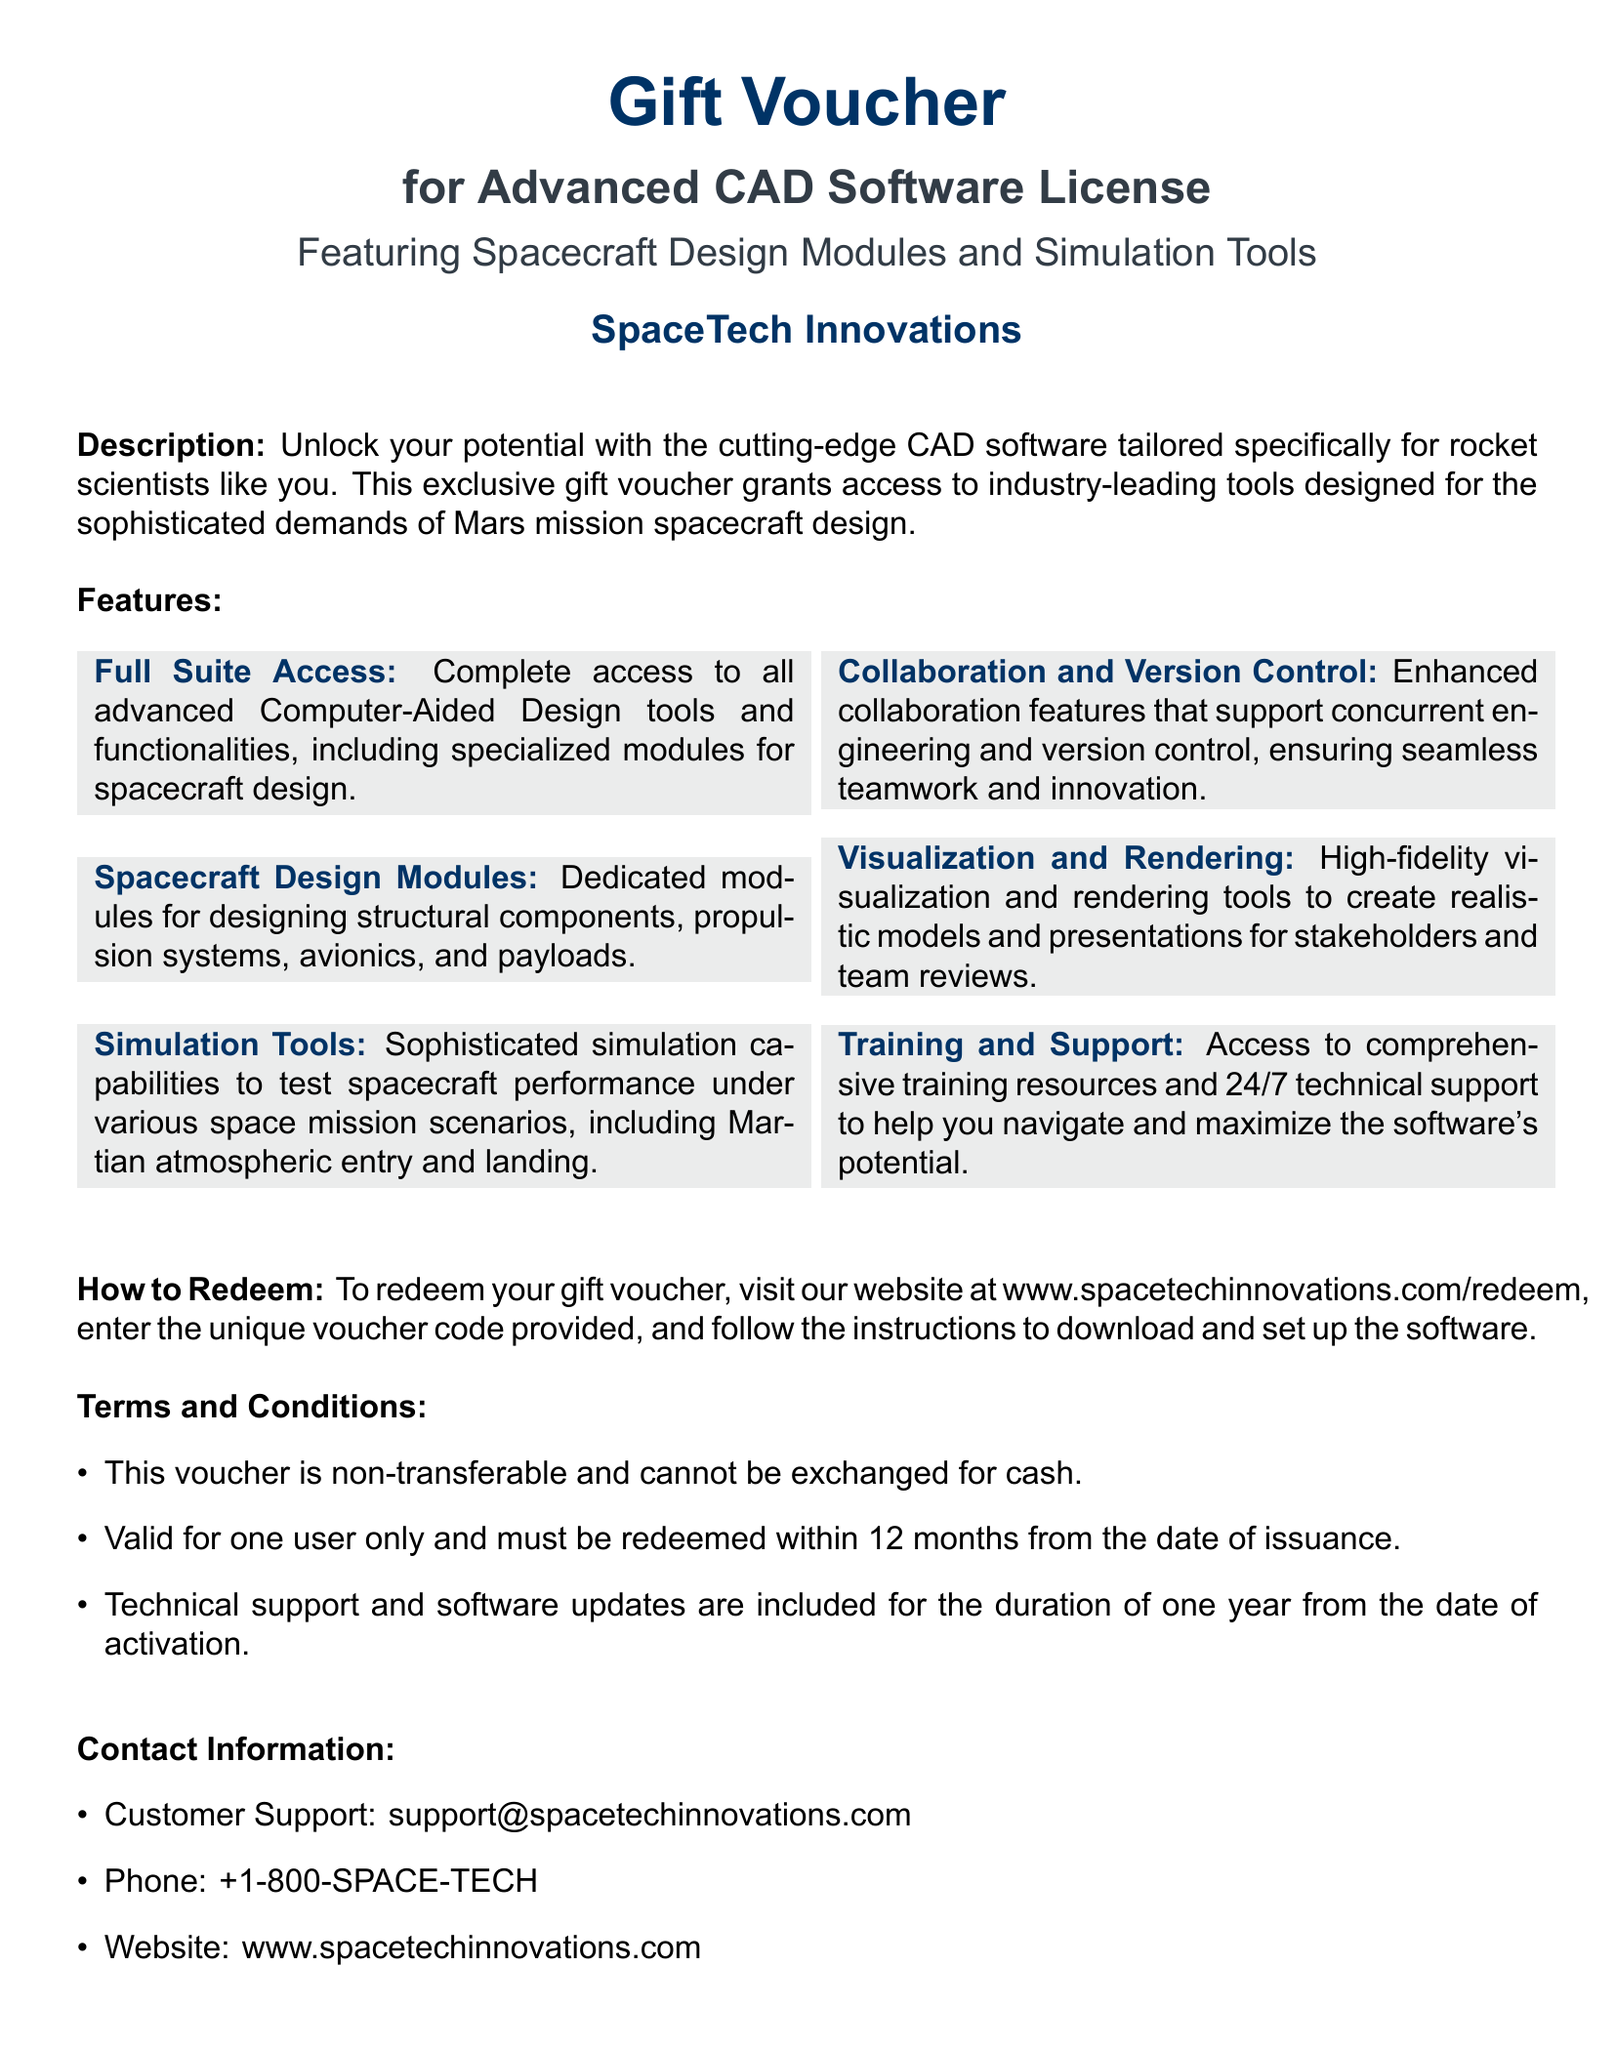What is the title of the gift voucher? The title of the gift voucher is explicitly stated at the top of the document.
Answer: Gift Voucher Who is the issuer of the voucher? The issuer of the voucher is mentioned below the title in the document.
Answer: SpaceTech Innovations What is included in the voucher? The document describes the contents of the voucher in the description section.
Answer: Advanced CAD Software License How many months is the redemption period? The terms section specifies the timeframe within which the voucher must be redeemed.
Answer: 12 months What does "Full Suite Access" provide? The features section details what is included under "Full Suite Access".
Answer: Complete access to all advanced Computer-Aided Design tools What type of support is offered? The features section mentions the support that comes with the voucher.
Answer: 24/7 technical support What is the website for redemption? The document contains a section that outlines the website where the voucher can be redeemed.
Answer: www.spacetechinnovations.com/redeem Is the voucher transferable? The terms and conditions state the transferability of the voucher.
Answer: Non-transferable What is the customer support email? The document includes contact information for customer support.
Answer: support@spacetechinnovations.com 